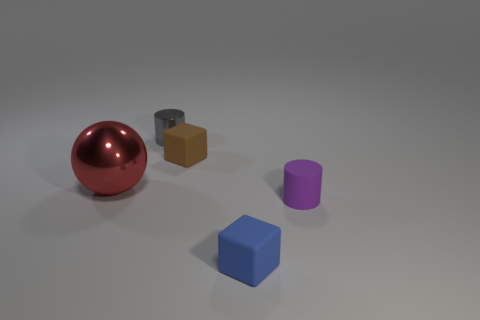Add 5 big spheres. How many objects exist? 10 Subtract all cylinders. How many objects are left? 3 Subtract 0 green blocks. How many objects are left? 5 Subtract all rubber cylinders. Subtract all brown cubes. How many objects are left? 3 Add 2 brown rubber objects. How many brown rubber objects are left? 3 Add 4 small brown cubes. How many small brown cubes exist? 5 